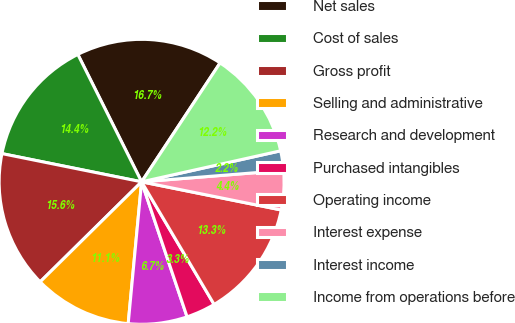Convert chart to OTSL. <chart><loc_0><loc_0><loc_500><loc_500><pie_chart><fcel>Net sales<fcel>Cost of sales<fcel>Gross profit<fcel>Selling and administrative<fcel>Research and development<fcel>Purchased intangibles<fcel>Operating income<fcel>Interest expense<fcel>Interest income<fcel>Income from operations before<nl><fcel>16.67%<fcel>14.44%<fcel>15.56%<fcel>11.11%<fcel>6.67%<fcel>3.33%<fcel>13.33%<fcel>4.44%<fcel>2.22%<fcel>12.22%<nl></chart> 